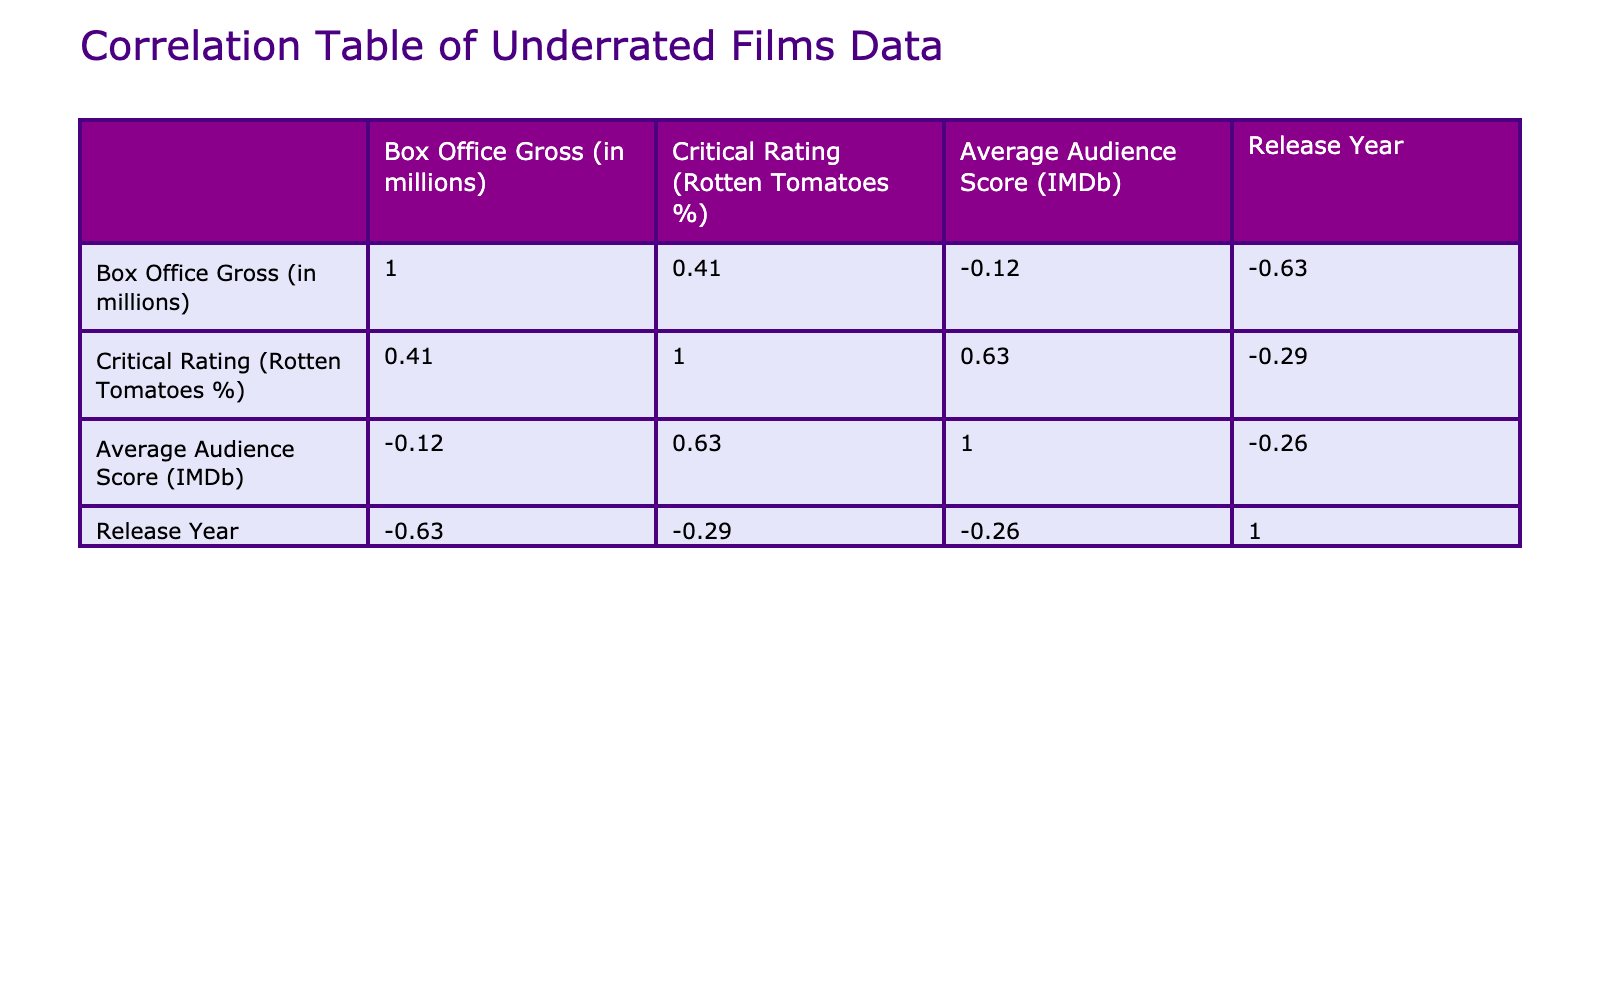What is the Box Office Gross of "Clerks"? The table lists "Clerks" with a Box Office Gross of 3.2 million.
Answer: 3.2 million Which film has the highest Critical Rating? The table shows that "Time Bandits" has the highest Critical Rating at 90%.
Answer: 90% Is the Average Audience Score of "The Last Dragon" greater than 7? The table shows "The Last Dragon" with an Average Audience Score of 7.5, which is indeed greater than 7.
Answer: Yes What is the average Box Office Gross of the films with a Critical Rating above 80%? The films with a Critical Rating above 80% are "Time Bandits," "Raising Arizona," "The Jerk," "Office Space," and "Midnight Run." Their Box Office Gross values are 42.4, 29.1, 40.1, 10.8, 30.2 respectively. The average is (42.4 + 29.1 + 40.1 + 10.8 + 30.2) / 5 = 30.52 million.
Answer: 30.52 million How many films have a Box Office Gross of less than 10 million? The table shows "Office Space" and "Bubble Boy," both with a Box Office Gross under 10 million. Thus, there are 2 films in this category.
Answer: 2 What is the difference in Box Office Gross between "Raising Arizona" and "Black Cauldron"? "Raising Arizona" has a Box Office Gross of 29.1 million and "Black Cauldron" has 21.3 million. The difference is 29.1 - 21.3 = 7.8 million.
Answer: 7.8 million Is it true that "Harold and Maude" has a higher Average Audience Score than "Bubble Boy"? "Harold and Maude" has an Average Audience Score of 8.0, while "Bubble Boy" has 6.5. Since 8.0 is greater than 6.5, the statement is true.
Answer: Yes What is the total Box Office Gross of all films released in the 1980s? The films from the 1980s are "The Last Dragon," "Time Bandits," "Raising Arizona," "The Jerk," "Midnight Run." Their Box Office Gross values are 25.0, 42.4, 29.1, 40.1, 30.2 respectively. The total is 25.0 + 42.4 + 29.1 + 40.1 + 30.2 = 166.8 million.
Answer: 166.8 million 